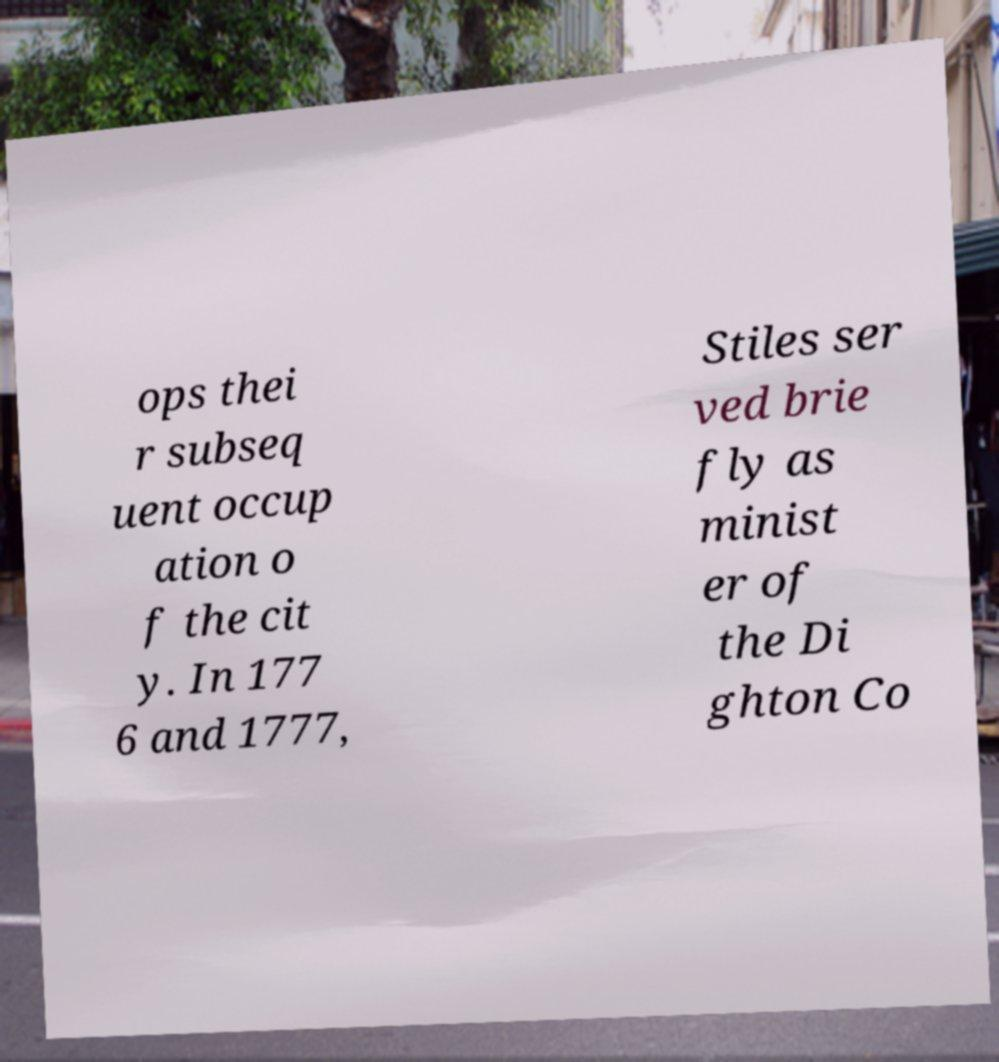I need the written content from this picture converted into text. Can you do that? ops thei r subseq uent occup ation o f the cit y. In 177 6 and 1777, Stiles ser ved brie fly as minist er of the Di ghton Co 